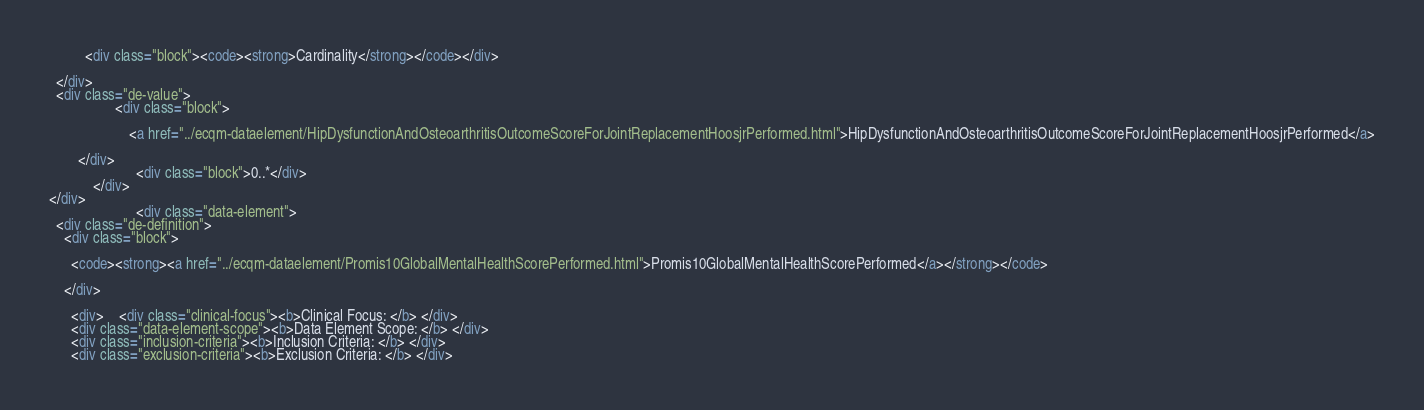Convert code to text. <code><loc_0><loc_0><loc_500><loc_500><_HTML_>          <div class="block"><code><strong>Cardinality</strong></code></div>
    
  </div>
  <div class="de-value">
                  <div class="block">
          
                      <a href="../ecqm-dataelement/HipDysfunctionAndOsteoarthritisOutcomeScoreForJointReplacementHoosjrPerformed.html">HipDysfunctionAndOsteoarthritisOutcomeScoreForJointReplacementHoosjrPerformed</a>
                    
        </div>
                        <div class="block">0..*</div>
            </div>
</div>
                        <div class="data-element">
  <div class="de-definition">
    <div class="block">
    
      <code><strong><a href="../ecqm-dataelement/Promis10GlobalMentalHealthScorePerformed.html">Promis10GlobalMentalHealthScorePerformed</a></strong></code>
    
    </div>
    
      <div>    <div class="clinical-focus"><b>Clinical Focus: </b> </div>
      <div class="data-element-scope"><b>Data Element Scope: </b> </div>
      <div class="inclusion-criteria"><b>Inclusion Criteria: </b> </div>
      <div class="exclusion-criteria"><b>Exclusion Criteria: </b> </div></code> 